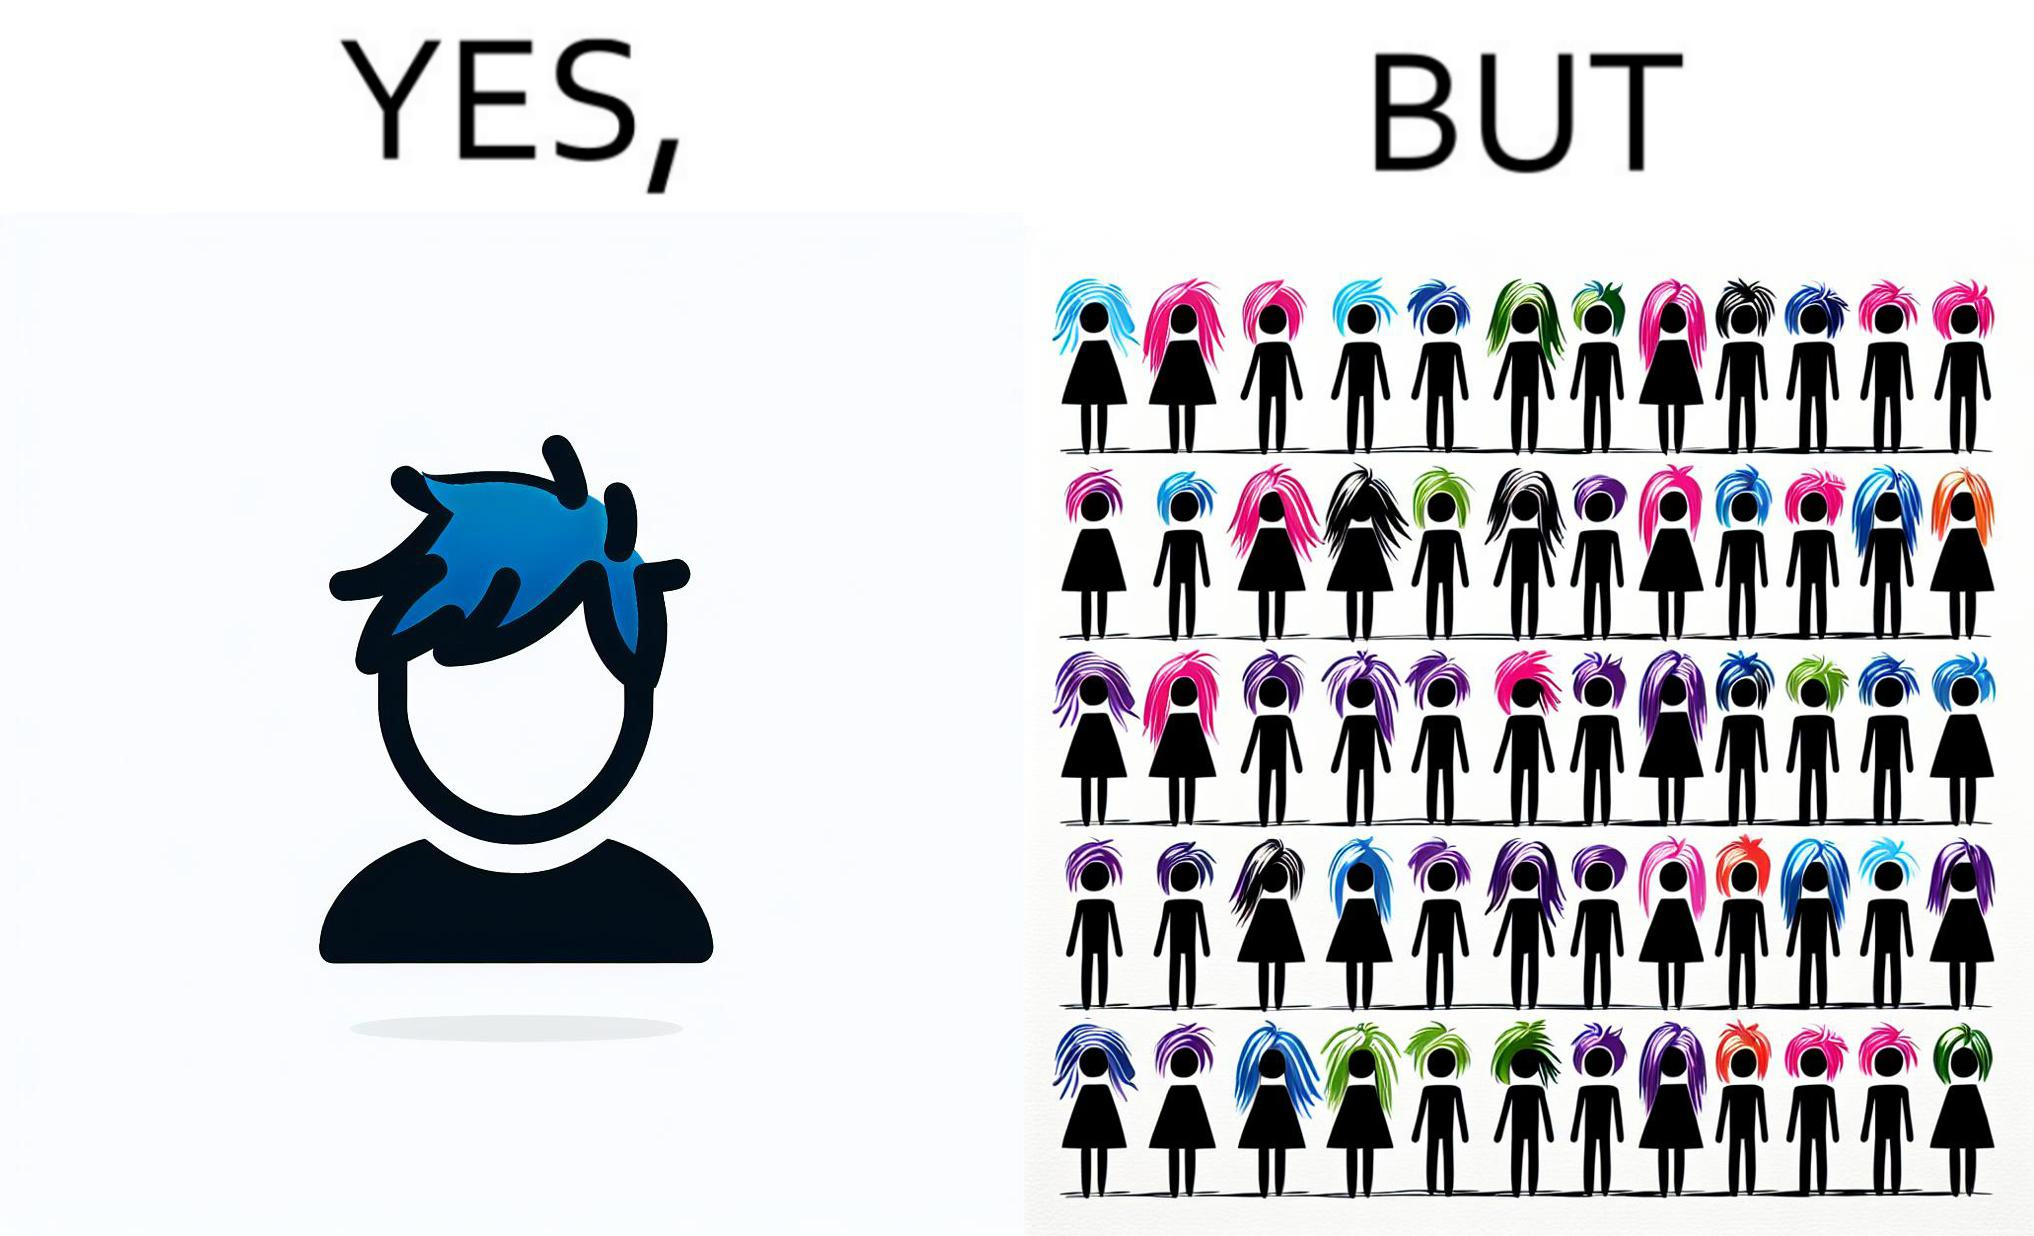Is this a satirical image? Yes, this image is satirical. 